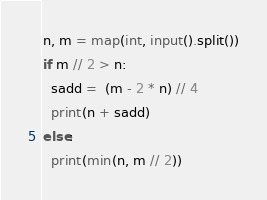Convert code to text. <code><loc_0><loc_0><loc_500><loc_500><_Python_>n, m = map(int, input().split())
if m // 2 > n:
  sadd =  (m - 2 * n) // 4
  print(n + sadd)
else:
  print(min(n, m // 2))</code> 